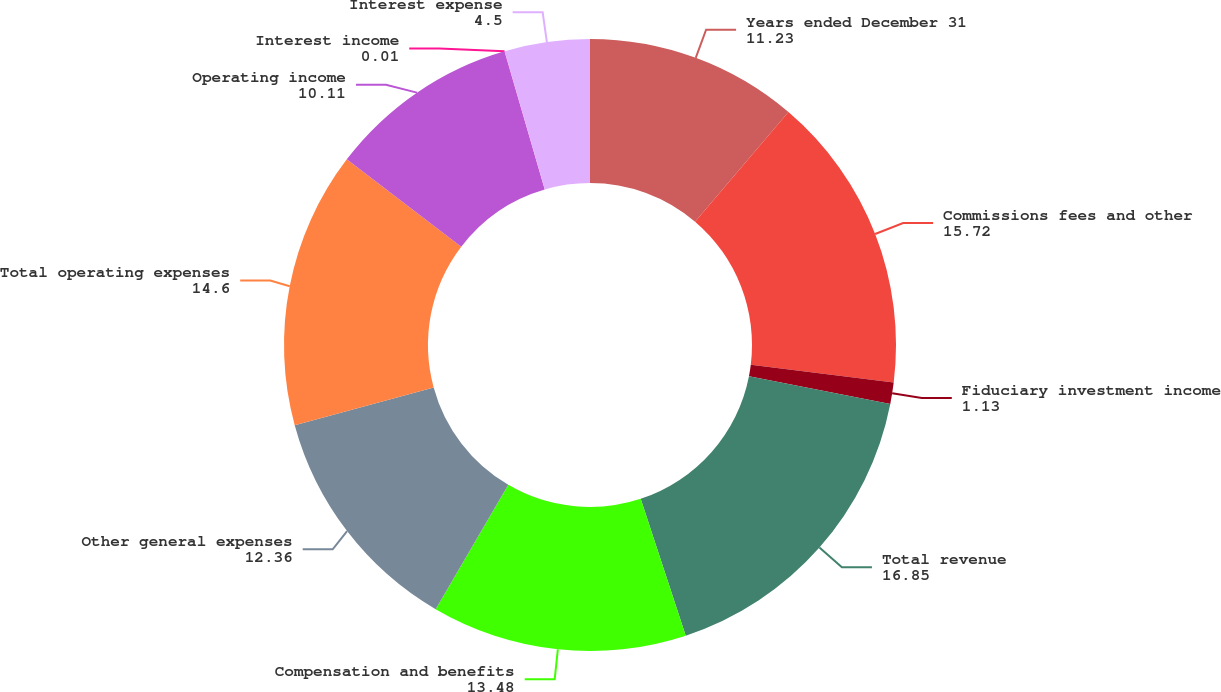Convert chart to OTSL. <chart><loc_0><loc_0><loc_500><loc_500><pie_chart><fcel>Years ended December 31<fcel>Commissions fees and other<fcel>Fiduciary investment income<fcel>Total revenue<fcel>Compensation and benefits<fcel>Other general expenses<fcel>Total operating expenses<fcel>Operating income<fcel>Interest income<fcel>Interest expense<nl><fcel>11.23%<fcel>15.72%<fcel>1.13%<fcel>16.85%<fcel>13.48%<fcel>12.36%<fcel>14.6%<fcel>10.11%<fcel>0.01%<fcel>4.5%<nl></chart> 